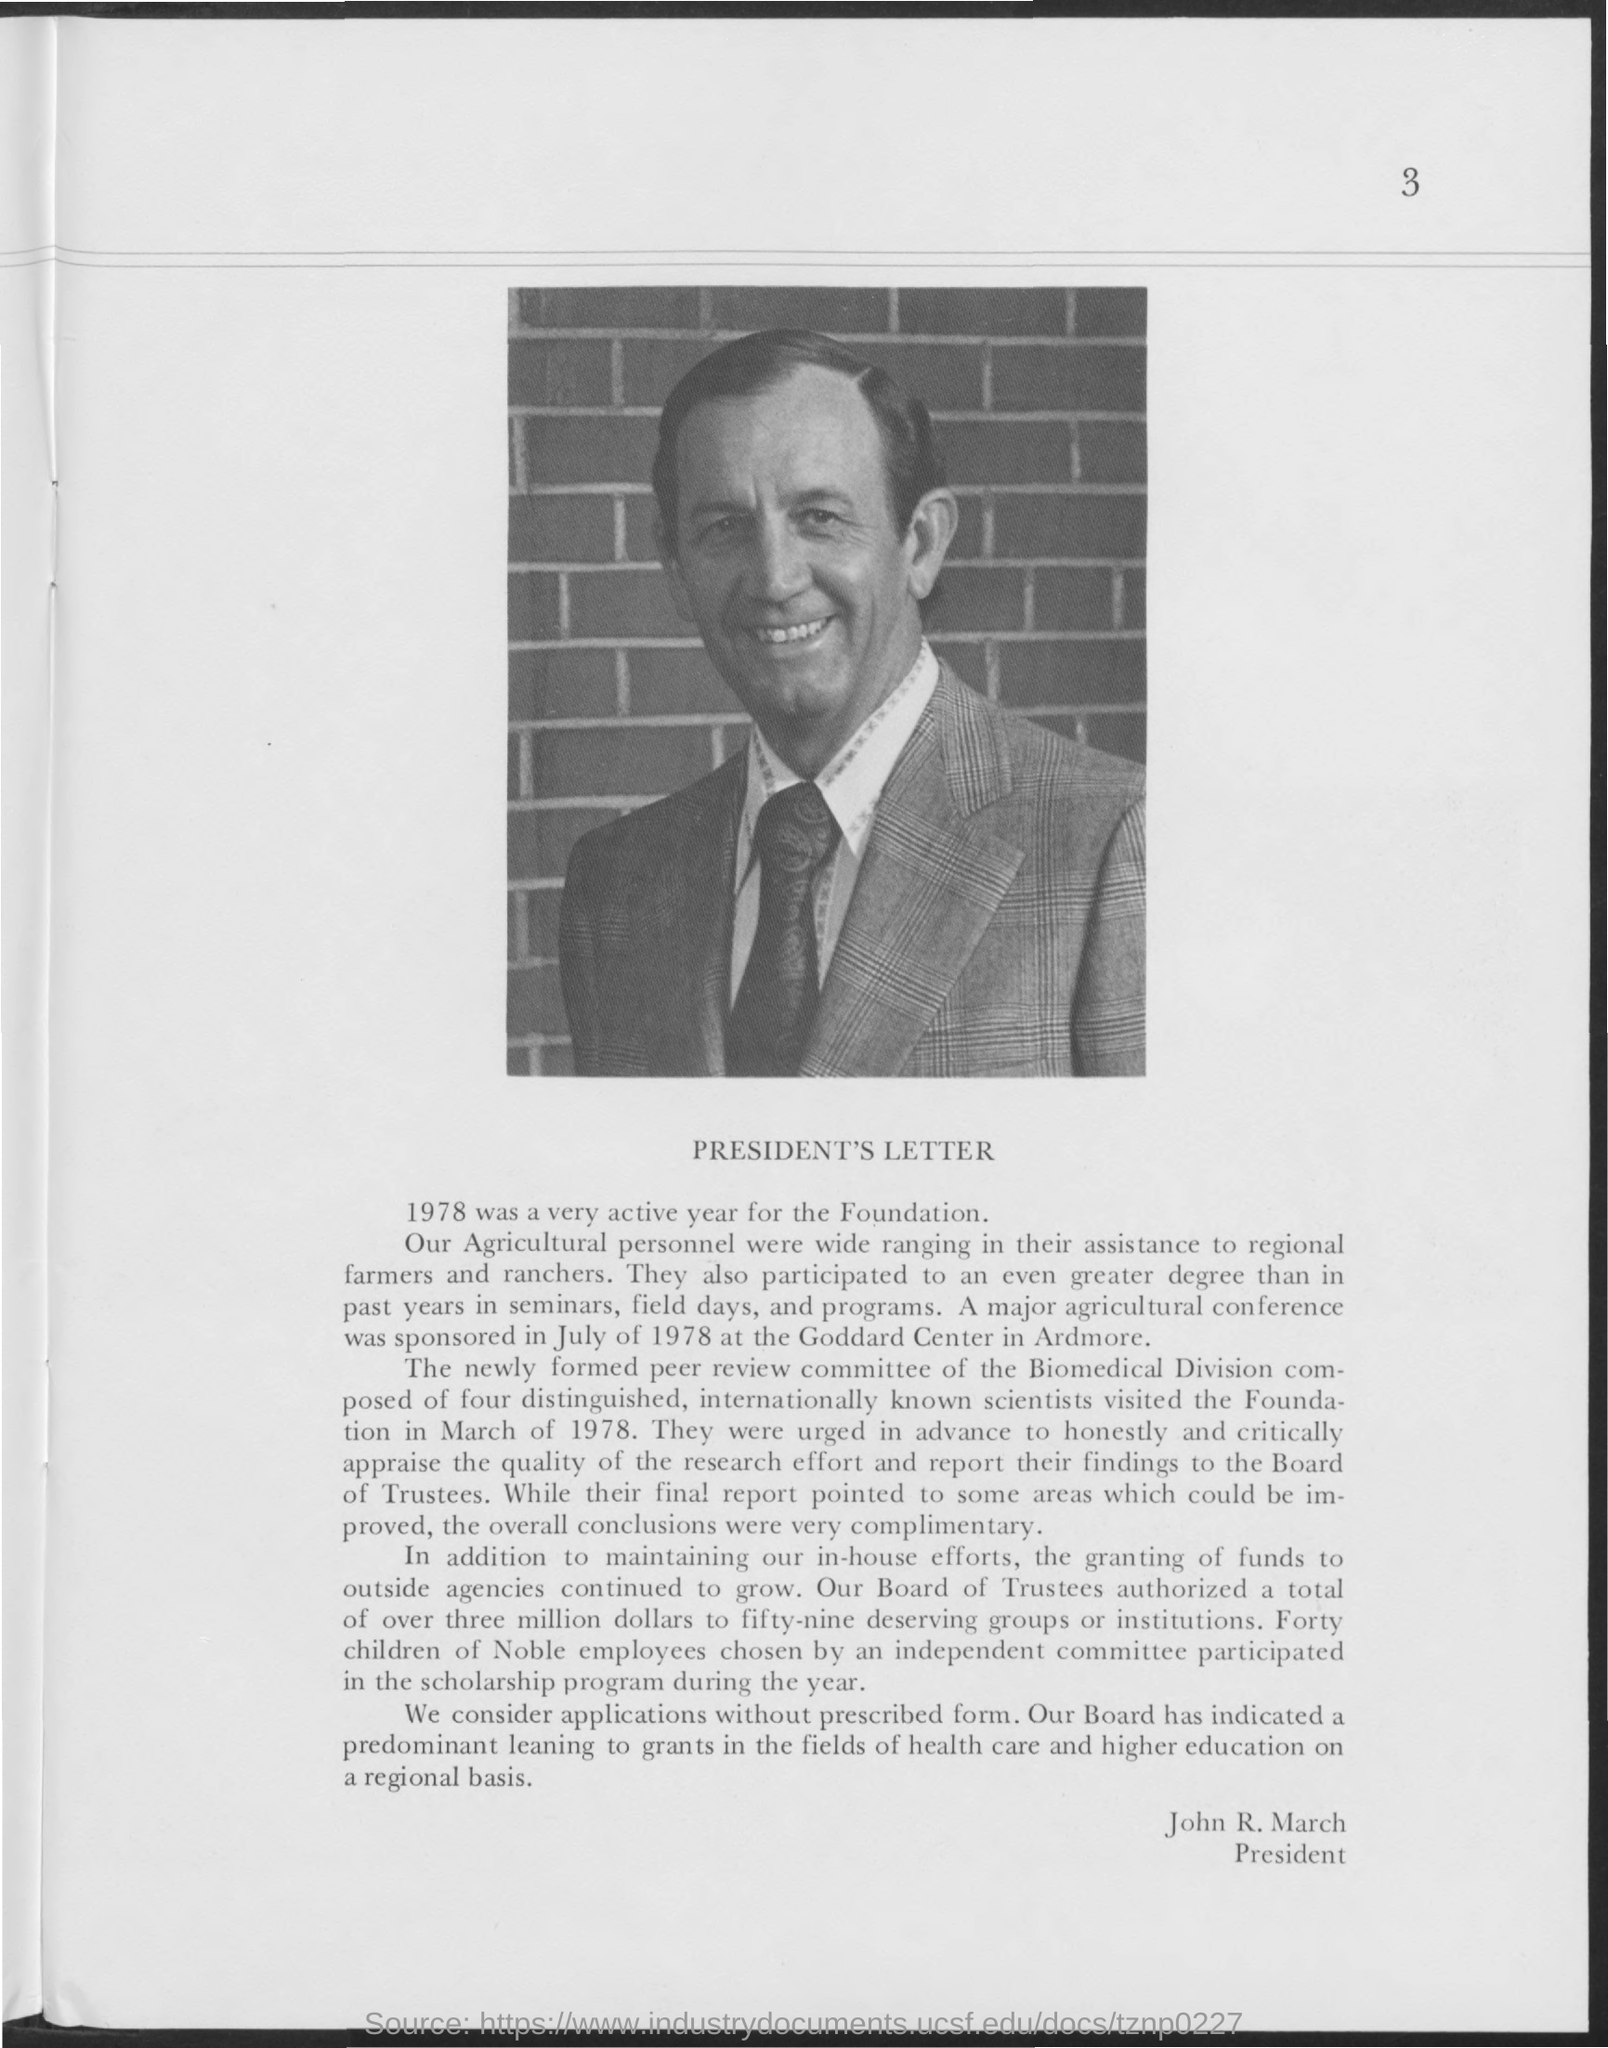Mention a couple of crucial points in this snapshot. The author of this letter is John R. March. The heading of the document is 'PRESIDENT'S LETTER.' 